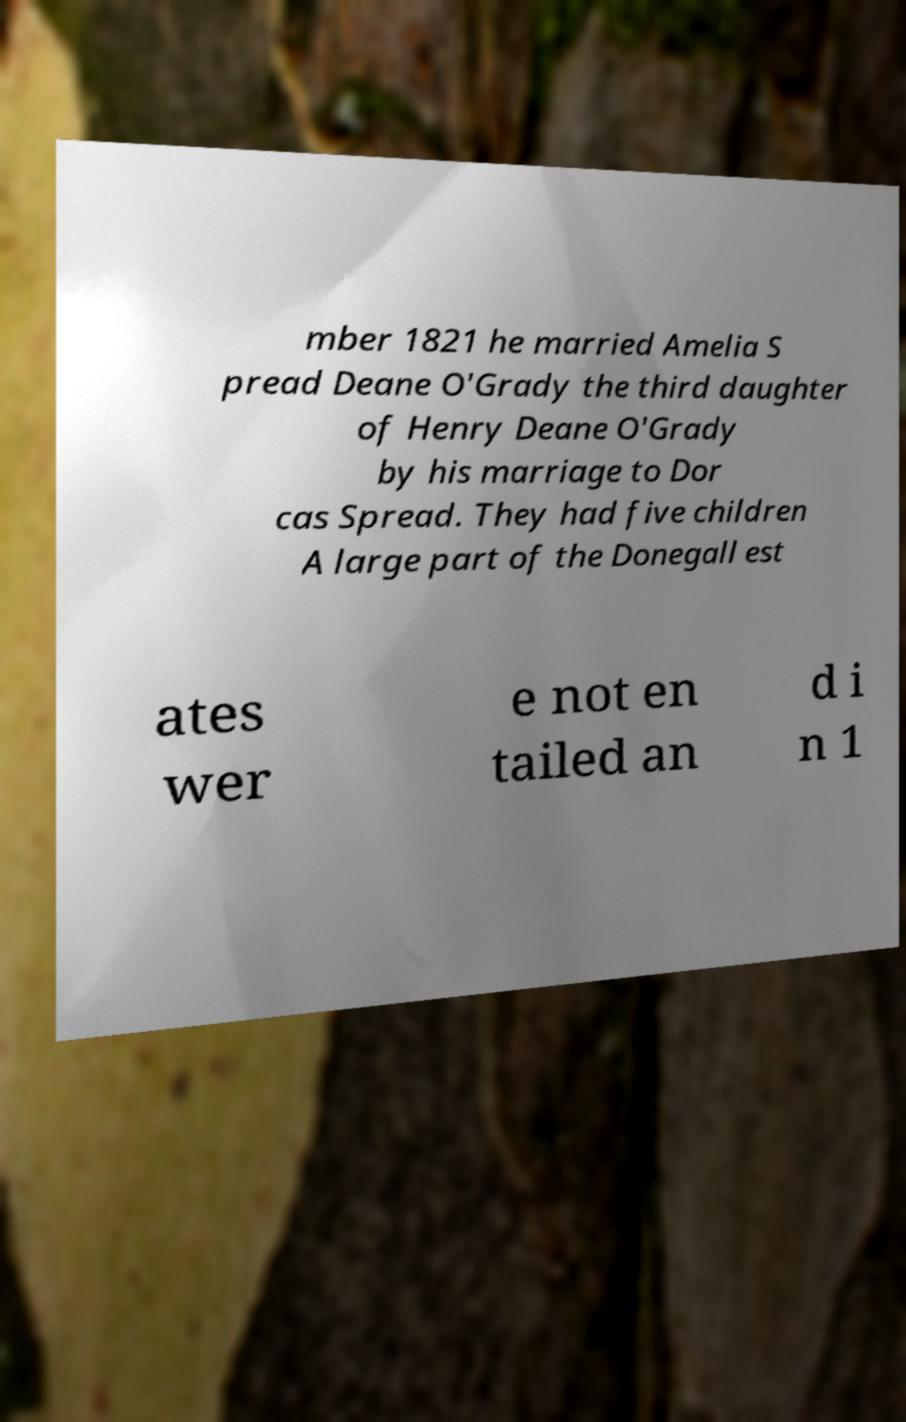Can you read and provide the text displayed in the image?This photo seems to have some interesting text. Can you extract and type it out for me? mber 1821 he married Amelia S pread Deane O'Grady the third daughter of Henry Deane O'Grady by his marriage to Dor cas Spread. They had five children A large part of the Donegall est ates wer e not en tailed an d i n 1 